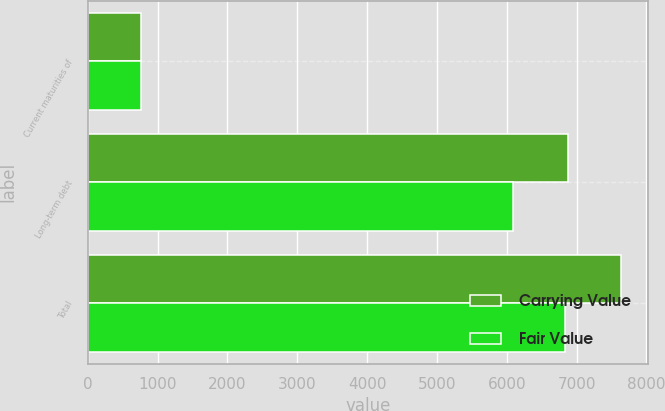<chart> <loc_0><loc_0><loc_500><loc_500><stacked_bar_chart><ecel><fcel>Current maturities of<fcel>Long-term debt<fcel>Total<nl><fcel>Carrying Value<fcel>756<fcel>6880<fcel>7636<nl><fcel>Fair Value<fcel>755<fcel>6082<fcel>6837<nl></chart> 